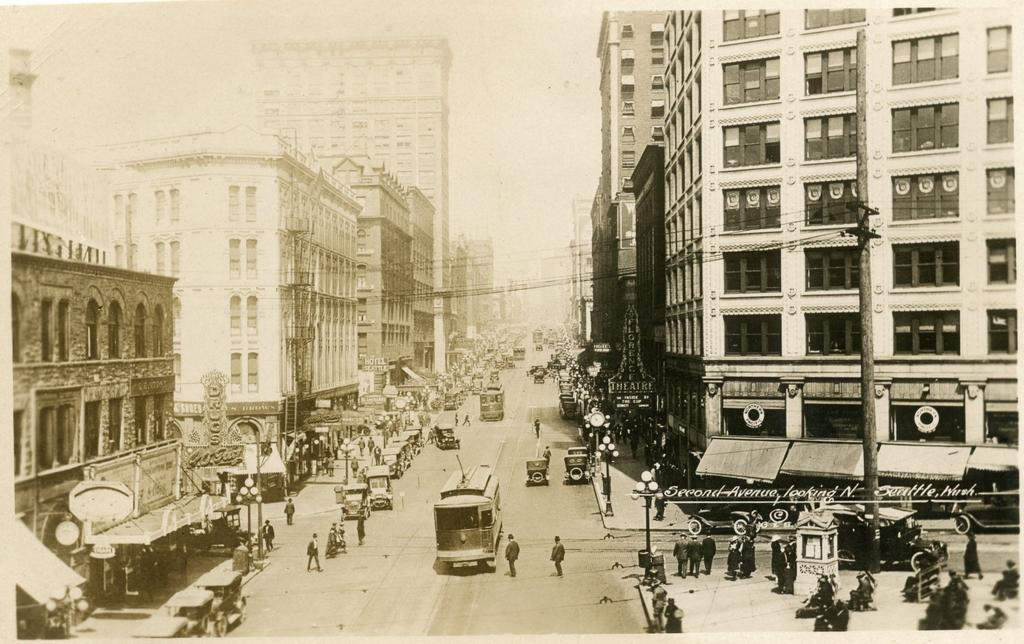What is the color scheme of the image? The image is black and white. What type of structures can be seen in the image? There are buildings in the image. What other objects are present in the image? There are poles, boards, and lights visible. Are there any people in the image? Yes, there are people in the image. What is happening on the road in the image? There are vehicles on the road in the image. What can be seen in the background of the image? The sky is visible in the background of the image. What type of hammer is being used by the person in the image? There is no hammer present in the image. What nation is being represented by the people in the image? The image does not depict any specific nation; it only shows people, buildings, and other objects. 